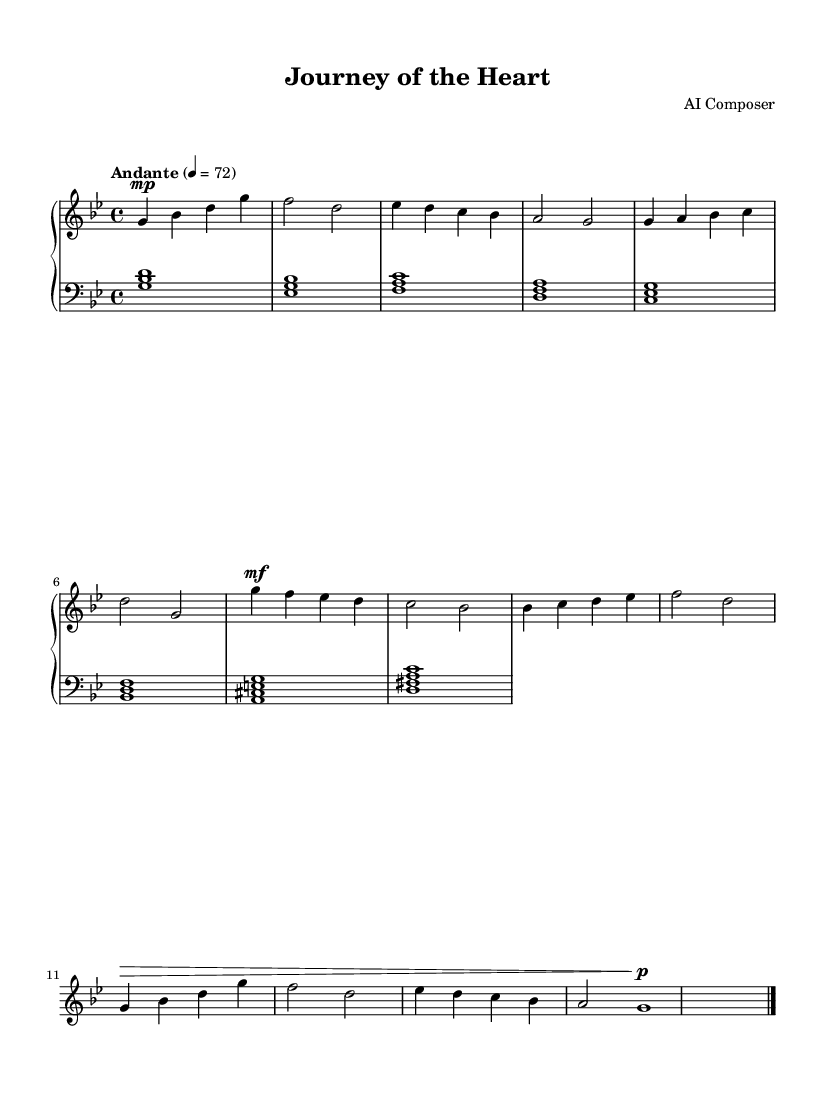What is the key signature of this music? The key signature is identified by the 'g' and 'b' flats in the staff, which indicates the key of G minor.
Answer: G minor What is the time signature of this piece? The time signature, shown as '4/4' at the beginning of the staff, indicates that there are four beats in each measure and a quarter note gets one beat.
Answer: 4/4 What is the tempo marking for this piece? The tempo marking 'Andante' indicates a moderately slow tempo, and the number '72' indicates the beats per minute, specifying how fast the music should be played.
Answer: Andante How many measures are there in the introduction section? The introduction consists of four measures, as represented by the sequence of musical notes from the start to the end of this section.
Answer: 4 measures What dynamics are indicated in the chorus section? The chorus section has a dynamic marking of 'mf' (mezzo-forte), which suggests playing this part moderately loud.
Answer: mf Which section comes after the bridge? The section following the bridge is the outro, as indicated by the transition of musical phrases leading to the concluding part of the piece.
Answer: Outro What type of harmony is used in the left hand? The left hand utilizes chordal harmony, as seen in the conjunction of different notes played simultaneously, which adds depth to the overall sound.
Answer: Chordal harmony 